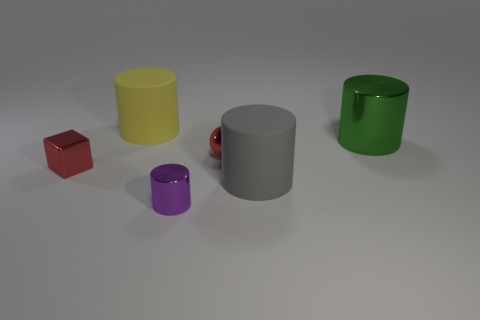Which object seems smallest and what is its color? The smallest object in the image looks to be the small, reflective sphere, which seems to carry a reddish hue, likely due to its reflective nature. If that's a sphere, why might its color appear ambiguous? The sphere's color appears ambiguous because it's reflective, meaning it absorbs and reflects colors from its surroundings. Its environment consists of other colorful objects and a neutral background, which can influence the perceived color. 